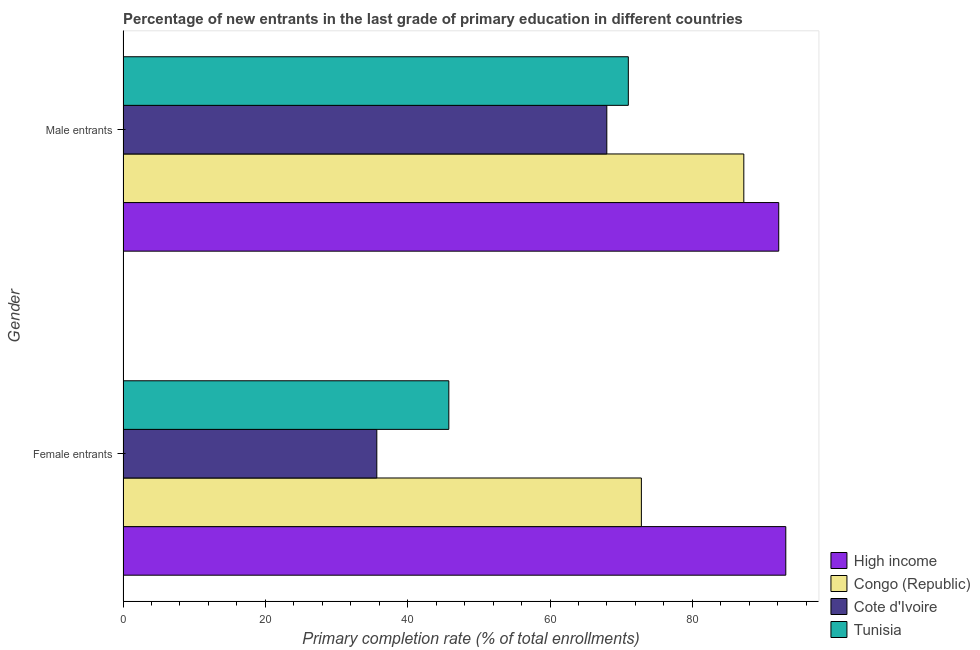How many bars are there on the 1st tick from the top?
Ensure brevity in your answer.  4. How many bars are there on the 1st tick from the bottom?
Ensure brevity in your answer.  4. What is the label of the 2nd group of bars from the top?
Your answer should be compact. Female entrants. What is the primary completion rate of female entrants in Tunisia?
Make the answer very short. 45.78. Across all countries, what is the maximum primary completion rate of male entrants?
Your response must be concise. 92.14. Across all countries, what is the minimum primary completion rate of female entrants?
Your answer should be compact. 35.66. In which country was the primary completion rate of female entrants minimum?
Provide a short and direct response. Cote d'Ivoire. What is the total primary completion rate of female entrants in the graph?
Your response must be concise. 247.42. What is the difference between the primary completion rate of male entrants in Tunisia and that in Congo (Republic)?
Your answer should be compact. -16.23. What is the difference between the primary completion rate of female entrants in High income and the primary completion rate of male entrants in Cote d'Ivoire?
Your response must be concise. 25.15. What is the average primary completion rate of male entrants per country?
Make the answer very short. 79.59. What is the difference between the primary completion rate of male entrants and primary completion rate of female entrants in Congo (Republic)?
Offer a very short reply. 14.39. In how many countries, is the primary completion rate of female entrants greater than 60 %?
Your response must be concise. 2. What is the ratio of the primary completion rate of female entrants in Tunisia to that in High income?
Provide a succinct answer. 0.49. In how many countries, is the primary completion rate of male entrants greater than the average primary completion rate of male entrants taken over all countries?
Provide a short and direct response. 2. What does the 2nd bar from the top in Female entrants represents?
Provide a short and direct response. Cote d'Ivoire. What does the 3rd bar from the bottom in Male entrants represents?
Your answer should be very brief. Cote d'Ivoire. Are all the bars in the graph horizontal?
Give a very brief answer. Yes. Does the graph contain any zero values?
Give a very brief answer. No. How are the legend labels stacked?
Ensure brevity in your answer.  Vertical. What is the title of the graph?
Offer a very short reply. Percentage of new entrants in the last grade of primary education in different countries. Does "Central African Republic" appear as one of the legend labels in the graph?
Your response must be concise. No. What is the label or title of the X-axis?
Make the answer very short. Primary completion rate (% of total enrollments). What is the label or title of the Y-axis?
Offer a very short reply. Gender. What is the Primary completion rate (% of total enrollments) in High income in Female entrants?
Provide a succinct answer. 93.13. What is the Primary completion rate (% of total enrollments) in Congo (Republic) in Female entrants?
Make the answer very short. 72.84. What is the Primary completion rate (% of total enrollments) in Cote d'Ivoire in Female entrants?
Provide a succinct answer. 35.66. What is the Primary completion rate (% of total enrollments) of Tunisia in Female entrants?
Offer a very short reply. 45.78. What is the Primary completion rate (% of total enrollments) of High income in Male entrants?
Make the answer very short. 92.14. What is the Primary completion rate (% of total enrollments) of Congo (Republic) in Male entrants?
Provide a succinct answer. 87.23. What is the Primary completion rate (% of total enrollments) in Cote d'Ivoire in Male entrants?
Provide a short and direct response. 67.98. What is the Primary completion rate (% of total enrollments) in Tunisia in Male entrants?
Your response must be concise. 71.01. Across all Gender, what is the maximum Primary completion rate (% of total enrollments) of High income?
Your answer should be very brief. 93.13. Across all Gender, what is the maximum Primary completion rate (% of total enrollments) of Congo (Republic)?
Your answer should be very brief. 87.23. Across all Gender, what is the maximum Primary completion rate (% of total enrollments) in Cote d'Ivoire?
Give a very brief answer. 67.98. Across all Gender, what is the maximum Primary completion rate (% of total enrollments) of Tunisia?
Make the answer very short. 71.01. Across all Gender, what is the minimum Primary completion rate (% of total enrollments) in High income?
Offer a terse response. 92.14. Across all Gender, what is the minimum Primary completion rate (% of total enrollments) of Congo (Republic)?
Offer a very short reply. 72.84. Across all Gender, what is the minimum Primary completion rate (% of total enrollments) of Cote d'Ivoire?
Offer a very short reply. 35.66. Across all Gender, what is the minimum Primary completion rate (% of total enrollments) in Tunisia?
Make the answer very short. 45.78. What is the total Primary completion rate (% of total enrollments) of High income in the graph?
Make the answer very short. 185.27. What is the total Primary completion rate (% of total enrollments) of Congo (Republic) in the graph?
Keep it short and to the point. 160.08. What is the total Primary completion rate (% of total enrollments) in Cote d'Ivoire in the graph?
Ensure brevity in your answer.  103.65. What is the total Primary completion rate (% of total enrollments) in Tunisia in the graph?
Your answer should be very brief. 116.79. What is the difference between the Primary completion rate (% of total enrollments) in Congo (Republic) in Female entrants and that in Male entrants?
Your response must be concise. -14.39. What is the difference between the Primary completion rate (% of total enrollments) of Cote d'Ivoire in Female entrants and that in Male entrants?
Offer a terse response. -32.32. What is the difference between the Primary completion rate (% of total enrollments) in Tunisia in Female entrants and that in Male entrants?
Offer a very short reply. -25.22. What is the difference between the Primary completion rate (% of total enrollments) of High income in Female entrants and the Primary completion rate (% of total enrollments) of Congo (Republic) in Male entrants?
Provide a succinct answer. 5.9. What is the difference between the Primary completion rate (% of total enrollments) of High income in Female entrants and the Primary completion rate (% of total enrollments) of Cote d'Ivoire in Male entrants?
Provide a short and direct response. 25.15. What is the difference between the Primary completion rate (% of total enrollments) of High income in Female entrants and the Primary completion rate (% of total enrollments) of Tunisia in Male entrants?
Provide a short and direct response. 22.13. What is the difference between the Primary completion rate (% of total enrollments) in Congo (Republic) in Female entrants and the Primary completion rate (% of total enrollments) in Cote d'Ivoire in Male entrants?
Your answer should be compact. 4.86. What is the difference between the Primary completion rate (% of total enrollments) in Congo (Republic) in Female entrants and the Primary completion rate (% of total enrollments) in Tunisia in Male entrants?
Ensure brevity in your answer.  1.83. What is the difference between the Primary completion rate (% of total enrollments) of Cote d'Ivoire in Female entrants and the Primary completion rate (% of total enrollments) of Tunisia in Male entrants?
Offer a terse response. -35.34. What is the average Primary completion rate (% of total enrollments) of High income per Gender?
Your response must be concise. 92.64. What is the average Primary completion rate (% of total enrollments) of Congo (Republic) per Gender?
Provide a succinct answer. 80.04. What is the average Primary completion rate (% of total enrollments) in Cote d'Ivoire per Gender?
Your answer should be compact. 51.82. What is the average Primary completion rate (% of total enrollments) of Tunisia per Gender?
Your answer should be very brief. 58.4. What is the difference between the Primary completion rate (% of total enrollments) of High income and Primary completion rate (% of total enrollments) of Congo (Republic) in Female entrants?
Keep it short and to the point. 20.29. What is the difference between the Primary completion rate (% of total enrollments) of High income and Primary completion rate (% of total enrollments) of Cote d'Ivoire in Female entrants?
Your answer should be compact. 57.47. What is the difference between the Primary completion rate (% of total enrollments) in High income and Primary completion rate (% of total enrollments) in Tunisia in Female entrants?
Offer a very short reply. 47.35. What is the difference between the Primary completion rate (% of total enrollments) in Congo (Republic) and Primary completion rate (% of total enrollments) in Cote d'Ivoire in Female entrants?
Offer a terse response. 37.18. What is the difference between the Primary completion rate (% of total enrollments) of Congo (Republic) and Primary completion rate (% of total enrollments) of Tunisia in Female entrants?
Provide a short and direct response. 27.06. What is the difference between the Primary completion rate (% of total enrollments) of Cote d'Ivoire and Primary completion rate (% of total enrollments) of Tunisia in Female entrants?
Make the answer very short. -10.12. What is the difference between the Primary completion rate (% of total enrollments) in High income and Primary completion rate (% of total enrollments) in Congo (Republic) in Male entrants?
Provide a short and direct response. 4.91. What is the difference between the Primary completion rate (% of total enrollments) of High income and Primary completion rate (% of total enrollments) of Cote d'Ivoire in Male entrants?
Your response must be concise. 24.16. What is the difference between the Primary completion rate (% of total enrollments) in High income and Primary completion rate (% of total enrollments) in Tunisia in Male entrants?
Make the answer very short. 21.13. What is the difference between the Primary completion rate (% of total enrollments) of Congo (Republic) and Primary completion rate (% of total enrollments) of Cote d'Ivoire in Male entrants?
Your response must be concise. 19.25. What is the difference between the Primary completion rate (% of total enrollments) of Congo (Republic) and Primary completion rate (% of total enrollments) of Tunisia in Male entrants?
Ensure brevity in your answer.  16.23. What is the difference between the Primary completion rate (% of total enrollments) of Cote d'Ivoire and Primary completion rate (% of total enrollments) of Tunisia in Male entrants?
Offer a terse response. -3.02. What is the ratio of the Primary completion rate (% of total enrollments) in High income in Female entrants to that in Male entrants?
Offer a very short reply. 1.01. What is the ratio of the Primary completion rate (% of total enrollments) in Congo (Republic) in Female entrants to that in Male entrants?
Make the answer very short. 0.83. What is the ratio of the Primary completion rate (% of total enrollments) of Cote d'Ivoire in Female entrants to that in Male entrants?
Provide a succinct answer. 0.52. What is the ratio of the Primary completion rate (% of total enrollments) in Tunisia in Female entrants to that in Male entrants?
Make the answer very short. 0.64. What is the difference between the highest and the second highest Primary completion rate (% of total enrollments) of High income?
Ensure brevity in your answer.  0.99. What is the difference between the highest and the second highest Primary completion rate (% of total enrollments) of Congo (Republic)?
Your answer should be compact. 14.39. What is the difference between the highest and the second highest Primary completion rate (% of total enrollments) in Cote d'Ivoire?
Offer a very short reply. 32.32. What is the difference between the highest and the second highest Primary completion rate (% of total enrollments) of Tunisia?
Make the answer very short. 25.22. What is the difference between the highest and the lowest Primary completion rate (% of total enrollments) of High income?
Offer a terse response. 0.99. What is the difference between the highest and the lowest Primary completion rate (% of total enrollments) of Congo (Republic)?
Ensure brevity in your answer.  14.39. What is the difference between the highest and the lowest Primary completion rate (% of total enrollments) of Cote d'Ivoire?
Offer a terse response. 32.32. What is the difference between the highest and the lowest Primary completion rate (% of total enrollments) in Tunisia?
Provide a short and direct response. 25.22. 